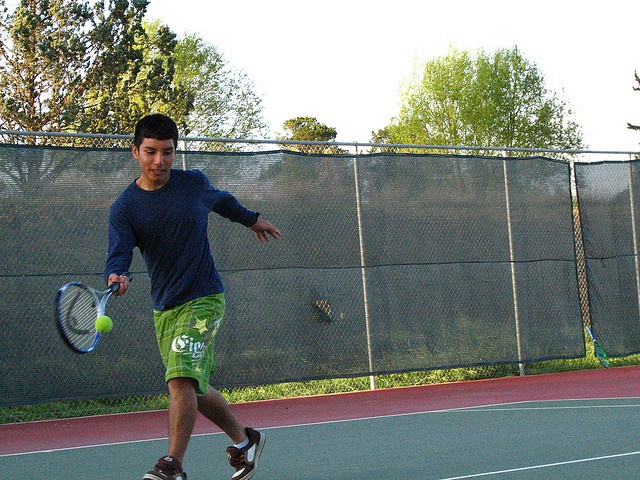Describe the objects in this image and their specific colors. I can see people in gray, black, navy, and maroon tones, tennis racket in gray, black, darkgray, and blue tones, and sports ball in gray, green, and lightgreen tones in this image. 